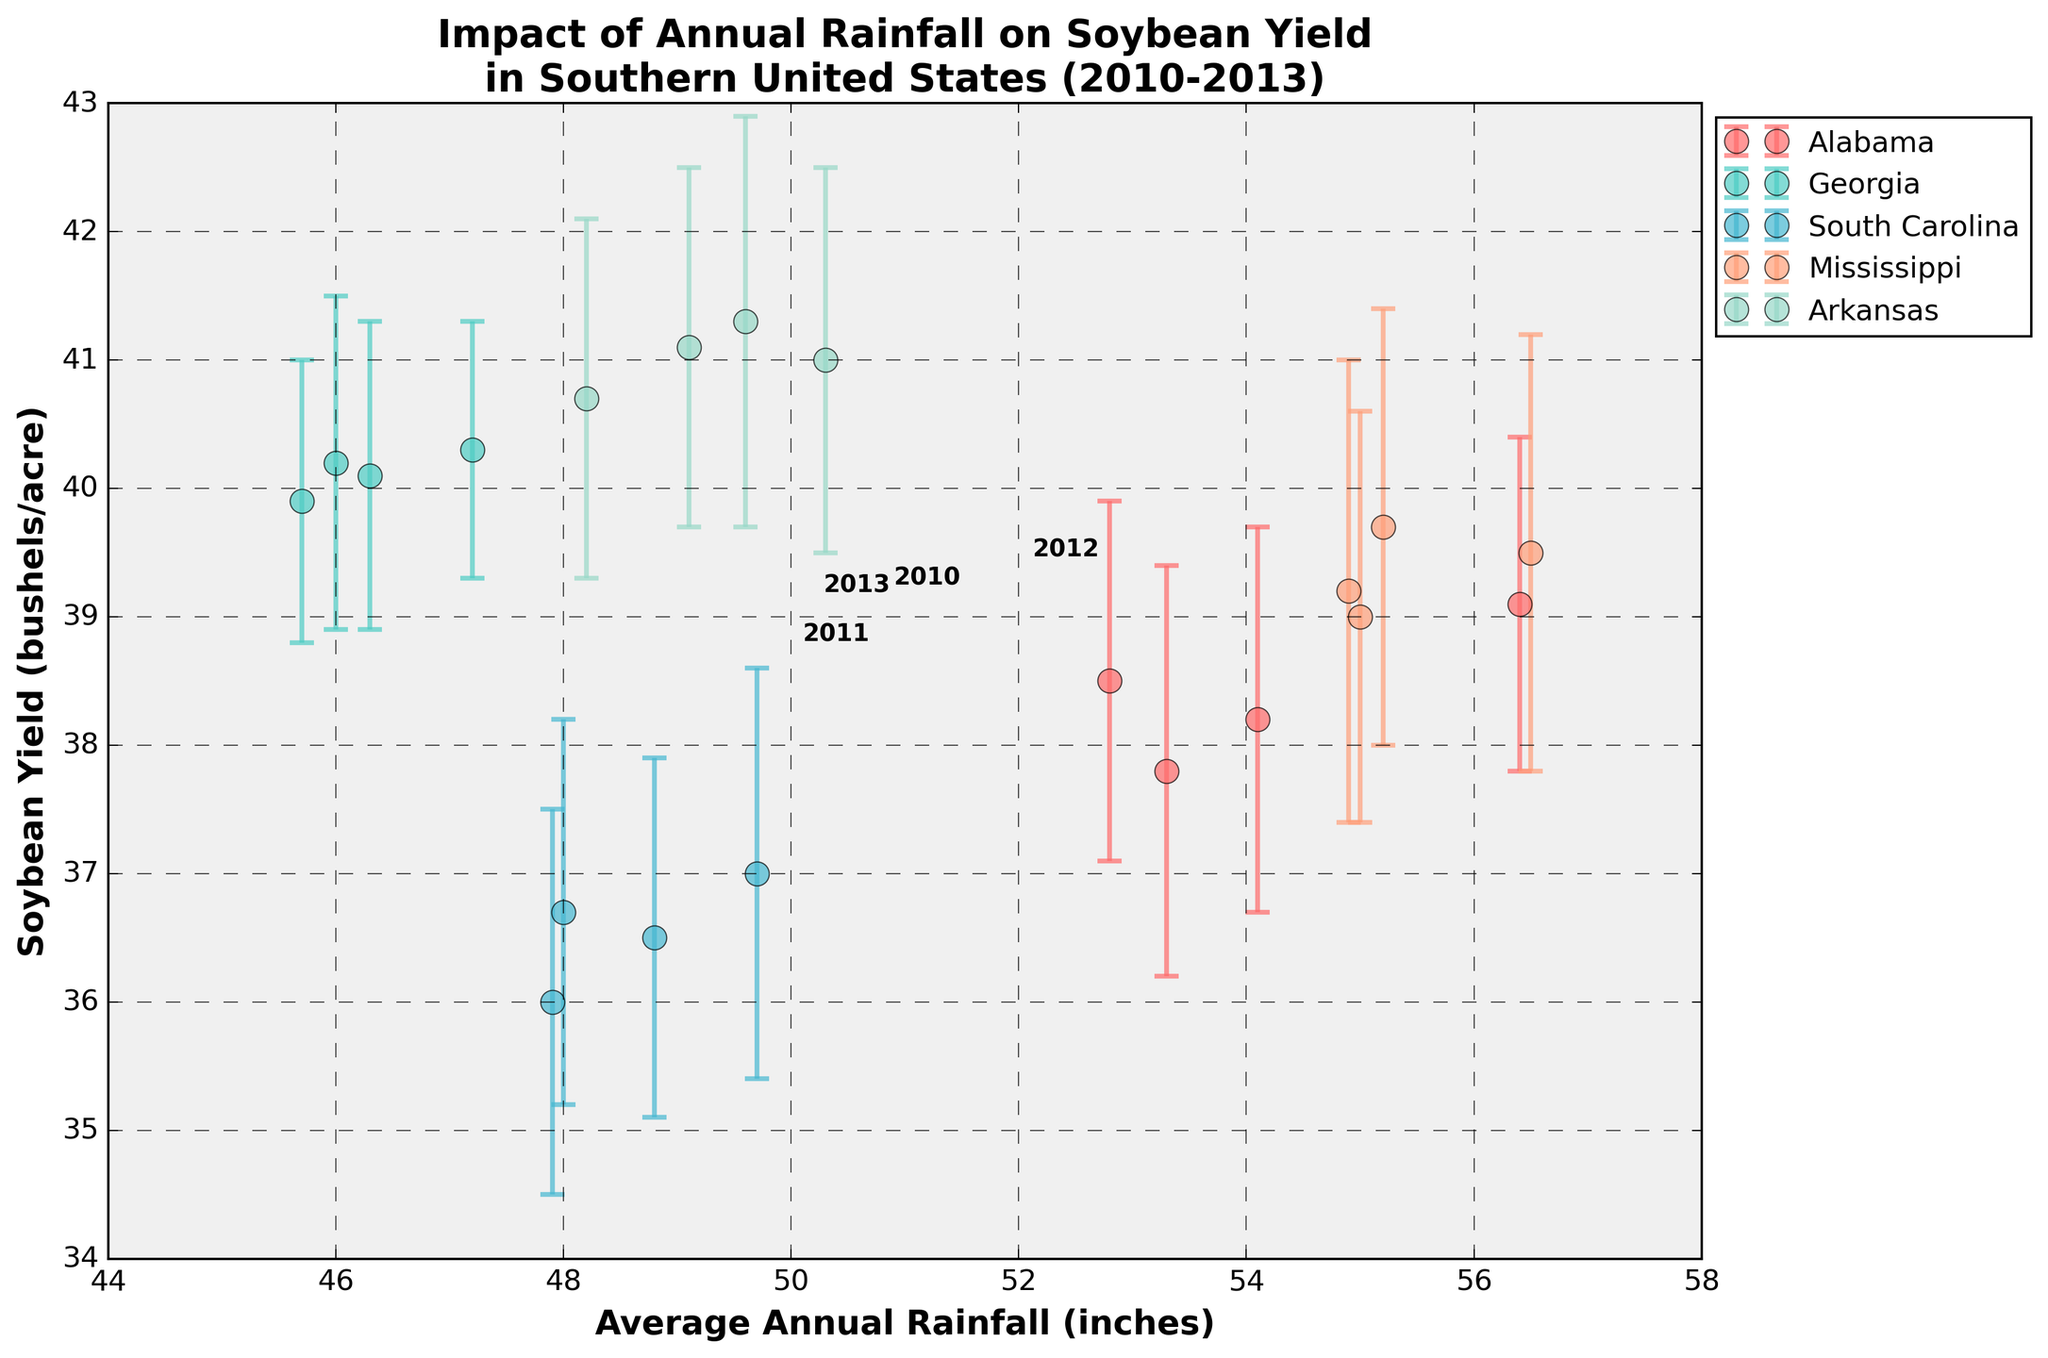What is the title of the plot? The title is located at the top of the figure and describes the main focus of the plot. Here, it reads "Impact of Annual Rainfall on Soybean Yield in Southern United States (2010-2013)."
Answer: Impact of Annual Rainfall on Soybean Yield in Southern United States (2010-2013) How many states are represented in the figure? The plot shows data points with different colors, and the legend indicates each state. There are five states: Alabama, Georgia, South Carolina, Mississippi, and Arkansas.
Answer: Five states What range of average annual rainfall (in inches) is depicted on the x-axis? The x-axis, labeled "Average Annual Rainfall (inches)," ranges from 44 to 58 inches.
Answer: 44 to 58 inches Which state has the highest soybean yield recorded in the plot, and what is that yield? By examining the data points and referring to the plot legend, Arkansas has the highest soybean yield recorded, which is approximately 41.3 bushels per acre.
Answer: Arkansas, 41.3 bushels per acre What is the soybean yield for South Carolina in 2010? By identifying the data points for South Carolina and noting the corresponding year, the yield in 2010 is shown as 36.5 bushels per acre.
Answer: 36.5 bushels per acre Which state and year combination has the smallest error bar for soybean yield? By comparing the error bars for each data point, Georgia in 2012 has the smallest error bar, which is about 1.0 bushels per acre.
Answer: Georgia, 2012 Is there any correlation visible between average annual rainfall and soybean yield? The plot shows a spread of data points without a clear linear trend, suggesting that there isn't a strong correlation between rainfall and soybean yield based on visual inspection.
Answer: No strong correlation Between which two states is the difference in soybean yield most noticeable? By comparing the data points and noting the differences, the yield difference between Arkansas and South Carolina is most noticeable, with yields around 41.3 and 36.5 bushels per acre respectively.
Answer: Arkansas and South Carolina What is the trend in soybean yield for Mississippi from 2010 to 2013? By following the data points for Mississippi, the soybean yield slightly decreases from 39.7 in 2010 to 39.0 in 2013.
Answer: Slight decrease How do the error bars for soybean yield change over the years for Alabama? By inspecting each year's data points for Alabama, the error bars slightly vary, ranging from about 1.3 to 1.6 bushels per acre, showing minor fluctuation over the years.
Answer: Slight fluctuation 